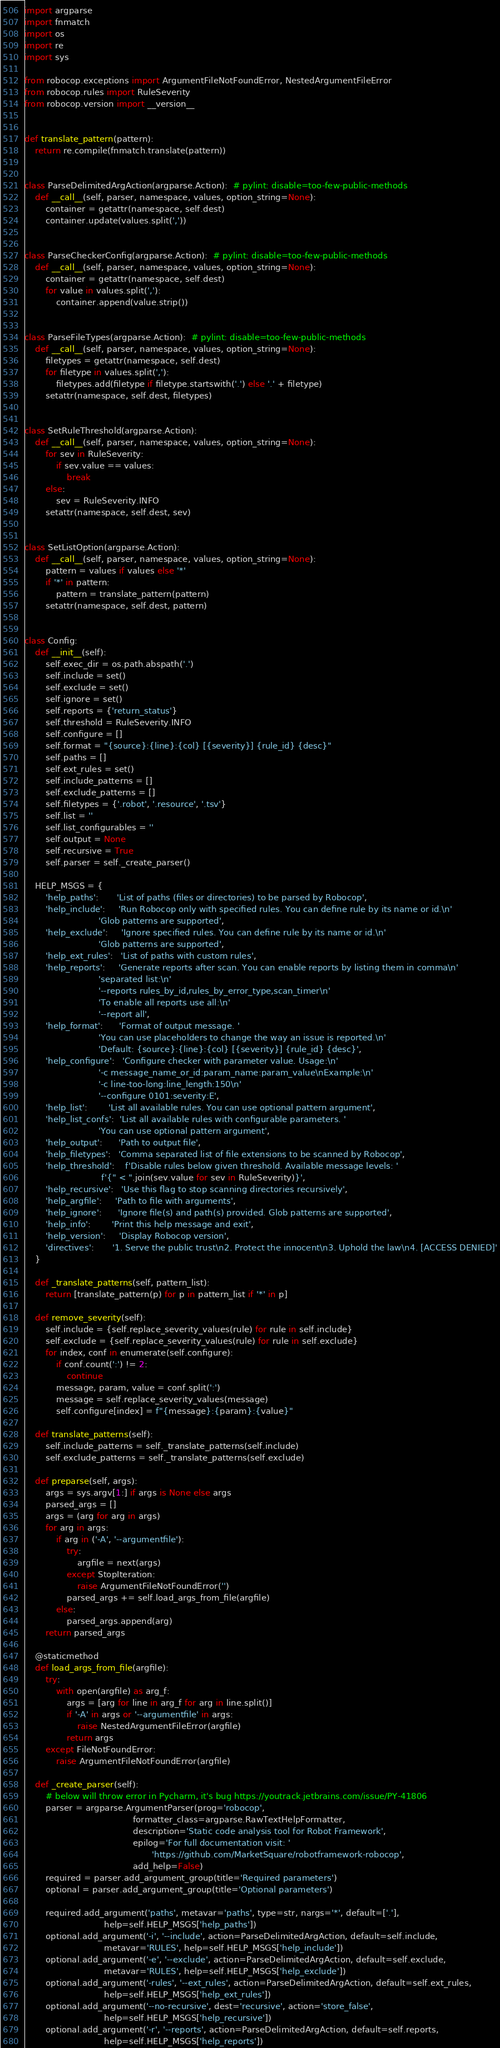<code> <loc_0><loc_0><loc_500><loc_500><_Python_>import argparse
import fnmatch
import os
import re
import sys

from robocop.exceptions import ArgumentFileNotFoundError, NestedArgumentFileError
from robocop.rules import RuleSeverity
from robocop.version import __version__


def translate_pattern(pattern):
    return re.compile(fnmatch.translate(pattern))


class ParseDelimitedArgAction(argparse.Action):  # pylint: disable=too-few-public-methods
    def __call__(self, parser, namespace, values, option_string=None):
        container = getattr(namespace, self.dest)
        container.update(values.split(','))


class ParseCheckerConfig(argparse.Action):  # pylint: disable=too-few-public-methods
    def __call__(self, parser, namespace, values, option_string=None):
        container = getattr(namespace, self.dest)
        for value in values.split(','):
            container.append(value.strip())


class ParseFileTypes(argparse.Action):  # pylint: disable=too-few-public-methods
    def __call__(self, parser, namespace, values, option_string=None):
        filetypes = getattr(namespace, self.dest)
        for filetype in values.split(','):
            filetypes.add(filetype if filetype.startswith('.') else '.' + filetype)
        setattr(namespace, self.dest, filetypes)


class SetRuleThreshold(argparse.Action):
    def __call__(self, parser, namespace, values, option_string=None):
        for sev in RuleSeverity:
            if sev.value == values:
                break
        else:
            sev = RuleSeverity.INFO
        setattr(namespace, self.dest, sev)


class SetListOption(argparse.Action):
    def __call__(self, parser, namespace, values, option_string=None):
        pattern = values if values else '*'
        if '*' in pattern:
            pattern = translate_pattern(pattern)
        setattr(namespace, self.dest, pattern)


class Config:
    def __init__(self):
        self.exec_dir = os.path.abspath('.')
        self.include = set()
        self.exclude = set()
        self.ignore = set()
        self.reports = {'return_status'}
        self.threshold = RuleSeverity.INFO
        self.configure = []
        self.format = "{source}:{line}:{col} [{severity}] {rule_id} {desc}"
        self.paths = []
        self.ext_rules = set()
        self.include_patterns = []
        self.exclude_patterns = []
        self.filetypes = {'.robot', '.resource', '.tsv'}
        self.list = ''
        self.list_configurables = ''
        self.output = None
        self.recursive = True
        self.parser = self._create_parser()

    HELP_MSGS = {
        'help_paths':       'List of paths (files or directories) to be parsed by Robocop',
        'help_include':     'Run Robocop only with specified rules. You can define rule by its name or id.\n'
                            'Glob patterns are supported',
        'help_exclude':     'Ignore specified rules. You can define rule by its name or id.\n'
                            'Glob patterns are supported',
        'help_ext_rules':   'List of paths with custom rules',
        'help_reports':     'Generate reports after scan. You can enable reports by listing them in comma\n'
                            'separated list:\n'
                            '--reports rules_by_id,rules_by_error_type,scan_timer\n'
                            'To enable all reports use all:\n'
                            '--report all',
        'help_format':      'Format of output message. '
                            'You can use placeholders to change the way an issue is reported.\n'
                            'Default: {source}:{line}:{col} [{severity}] {rule_id} {desc}',
        'help_configure':   'Configure checker with parameter value. Usage:\n'
                            '-c message_name_or_id:param_name:param_value\nExample:\n'
                            '-c line-too-long:line_length:150\n'
                            '--configure 0101:severity:E',
        'help_list':        'List all available rules. You can use optional pattern argument',
        'help_list_confs':  'List all available rules with configurable parameters. '
                            'You can use optional pattern argument',
        'help_output':      'Path to output file',
        'help_filetypes':   'Comma separated list of file extensions to be scanned by Robocop',
        'help_threshold':    f'Disable rules below given threshold. Available message levels: '
                             f'{" < ".join(sev.value for sev in RuleSeverity)}',
        'help_recursive':   'Use this flag to stop scanning directories recursively',
        'help_argfile':     'Path to file with arguments',
        'help_ignore':      'Ignore file(s) and path(s) provided. Glob patterns are supported',
        'help_info':        'Print this help message and exit',
        'help_version':     'Display Robocop version',
        'directives':       '1. Serve the public trust\n2. Protect the innocent\n3. Uphold the law\n4. [ACCESS DENIED]'
    }

    def _translate_patterns(self, pattern_list):
        return [translate_pattern(p) for p in pattern_list if '*' in p]

    def remove_severity(self):
        self.include = {self.replace_severity_values(rule) for rule in self.include}
        self.exclude = {self.replace_severity_values(rule) for rule in self.exclude}
        for index, conf in enumerate(self.configure):
            if conf.count(':') != 2:
                continue
            message, param, value = conf.split(':')
            message = self.replace_severity_values(message)
            self.configure[index] = f"{message}:{param}:{value}"

    def translate_patterns(self):
        self.include_patterns = self._translate_patterns(self.include)
        self.exclude_patterns = self._translate_patterns(self.exclude)

    def preparse(self, args):
        args = sys.argv[1:] if args is None else args
        parsed_args = []
        args = (arg for arg in args)
        for arg in args:
            if arg in ('-A', '--argumentfile'):
                try:
                    argfile = next(args)
                except StopIteration:
                    raise ArgumentFileNotFoundError('')
                parsed_args += self.load_args_from_file(argfile)
            else:
                parsed_args.append(arg)
        return parsed_args

    @staticmethod
    def load_args_from_file(argfile):
        try:
            with open(argfile) as arg_f:
                args = [arg for line in arg_f for arg in line.split()]
                if '-A' in args or '--argumentfile' in args:
                    raise NestedArgumentFileError(argfile)
                return args
        except FileNotFoundError:
            raise ArgumentFileNotFoundError(argfile)

    def _create_parser(self):
        # below will throw error in Pycharm, it's bug https://youtrack.jetbrains.com/issue/PY-41806
        parser = argparse.ArgumentParser(prog='robocop',
                                         formatter_class=argparse.RawTextHelpFormatter,
                                         description='Static code analysis tool for Robot Framework',
                                         epilog='For full documentation visit: '
                                                'https://github.com/MarketSquare/robotframework-robocop',
                                         add_help=False)
        required = parser.add_argument_group(title='Required parameters')
        optional = parser.add_argument_group(title='Optional parameters')

        required.add_argument('paths', metavar='paths', type=str, nargs='*', default=['.'],
                              help=self.HELP_MSGS['help_paths'])
        optional.add_argument('-i', '--include', action=ParseDelimitedArgAction, default=self.include,
                              metavar='RULES', help=self.HELP_MSGS['help_include'])
        optional.add_argument('-e', '--exclude', action=ParseDelimitedArgAction, default=self.exclude,
                              metavar='RULES', help=self.HELP_MSGS['help_exclude'])
        optional.add_argument('-rules', '--ext_rules', action=ParseDelimitedArgAction, default=self.ext_rules,
                              help=self.HELP_MSGS['help_ext_rules'])
        optional.add_argument('--no-recursive', dest='recursive', action='store_false',
                              help=self.HELP_MSGS['help_recursive'])
        optional.add_argument('-r', '--reports', action=ParseDelimitedArgAction, default=self.reports,
                              help=self.HELP_MSGS['help_reports'])</code> 